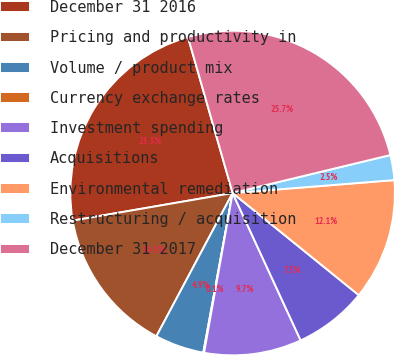Convert chart to OTSL. <chart><loc_0><loc_0><loc_500><loc_500><pie_chart><fcel>December 31 2016<fcel>Pricing and productivity in<fcel>Volume / product mix<fcel>Currency exchange rates<fcel>Investment spending<fcel>Acquisitions<fcel>Environmental remediation<fcel>Restructuring / acquisition<fcel>December 31 2017<nl><fcel>23.28%<fcel>14.5%<fcel>4.89%<fcel>0.08%<fcel>9.7%<fcel>7.29%<fcel>12.1%<fcel>2.49%<fcel>25.68%<nl></chart> 